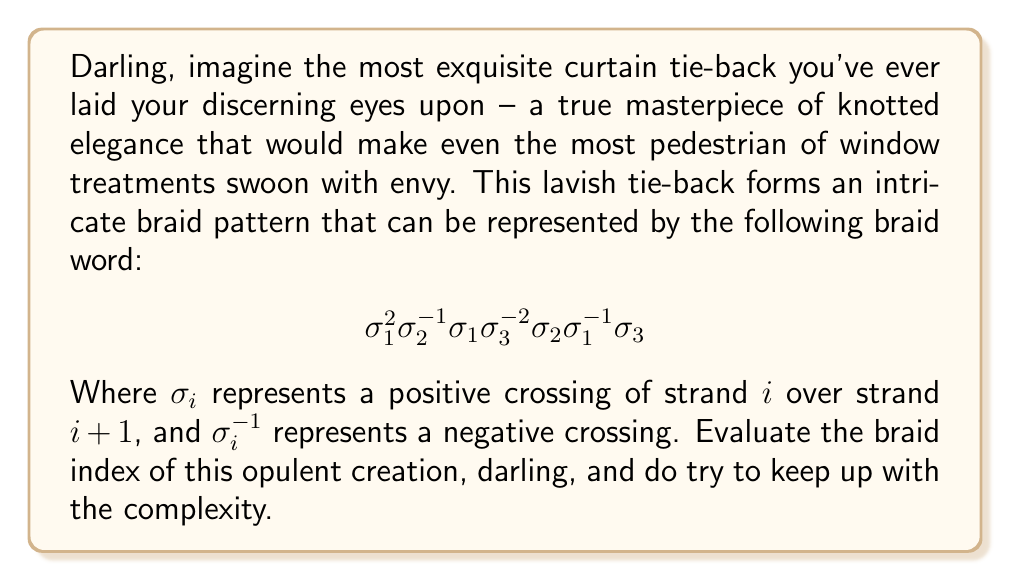Could you help me with this problem? To determine the braid index of this elaborate curtain tie-back, we shall follow these refined steps:

1. First, darling, we must recognize that the braid word given represents a 4-strand braid, as the highest index used is 3 (remember, in braid notation, we start counting from 1).

2. Now, the braid index is defined as the minimum number of strands needed to represent the knot as a closed braid. It's always less than or equal to the number of strands in the given braid word.

3. To minimize the number of strands, we need to check if any of the strands can be eliminated without changing the knot type. Let's analyze each strand:

   - Strand 1 is involved in crossings ($\sigma_1$ and $\sigma_1^{-1}$)
   - Strand 2 is involved in crossings ($\sigma_2$ and $\sigma_2^{-1}$)
   - Strand 3 is involved in crossings ($\sigma_3$ and $\sigma_3^{-1}$)
   - Strand 4 is passive and doesn't cross over or under any other strand

4. Observe, darling, that strand 4 is completely uninvolved in this knot – how dreadfully boring! We can eliminate it without changing the knot type.

5. After removing strand 4, we're left with a 3-strand braid that still represents the same knot:

   $$ \sigma_1^2 \sigma_2^{-1} \sigma_1 \sigma_2 \sigma_1^{-1} $$

6. Now, can we reduce it further? Let's see:
   - Strand 1 is essential (crossings with $\sigma_1$)
   - Strand 2 is essential (crossings with $\sigma_2$)
   - Strand 3 is essential (involved in $\sigma_2$ crossings)

7. Voilà! We cannot reduce the braid any further without changing its structure. Therefore, the minimum number of strands required to represent this knot is 3.

Thus, my dear, the braid index of this fabulously knotted curtain tie-back is 3. How delightfully complex for such a seemingly simple accessory!
Answer: 3 